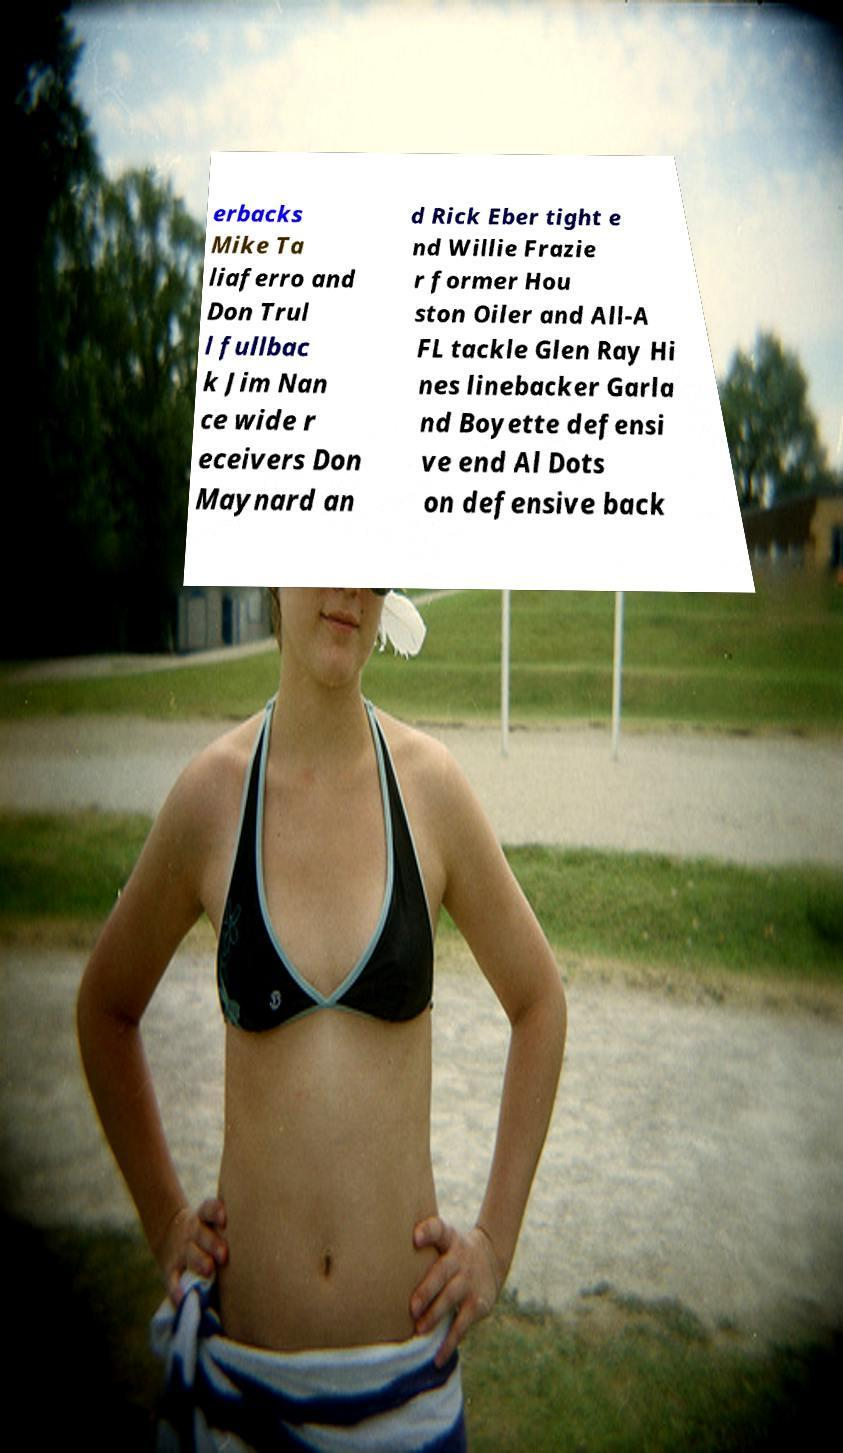Please identify and transcribe the text found in this image. erbacks Mike Ta liaferro and Don Trul l fullbac k Jim Nan ce wide r eceivers Don Maynard an d Rick Eber tight e nd Willie Frazie r former Hou ston Oiler and All-A FL tackle Glen Ray Hi nes linebacker Garla nd Boyette defensi ve end Al Dots on defensive back 